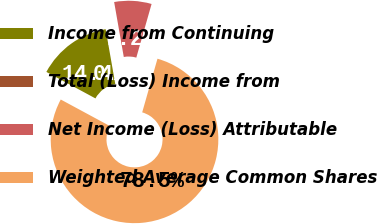Convert chart. <chart><loc_0><loc_0><loc_500><loc_500><pie_chart><fcel>Income from Continuing<fcel>Total (Loss) Income from<fcel>Net Income (Loss) Attributable<fcel>Weighted Average Common Shares<nl><fcel>14.36%<fcel>0.0%<fcel>7.18%<fcel>78.46%<nl></chart> 